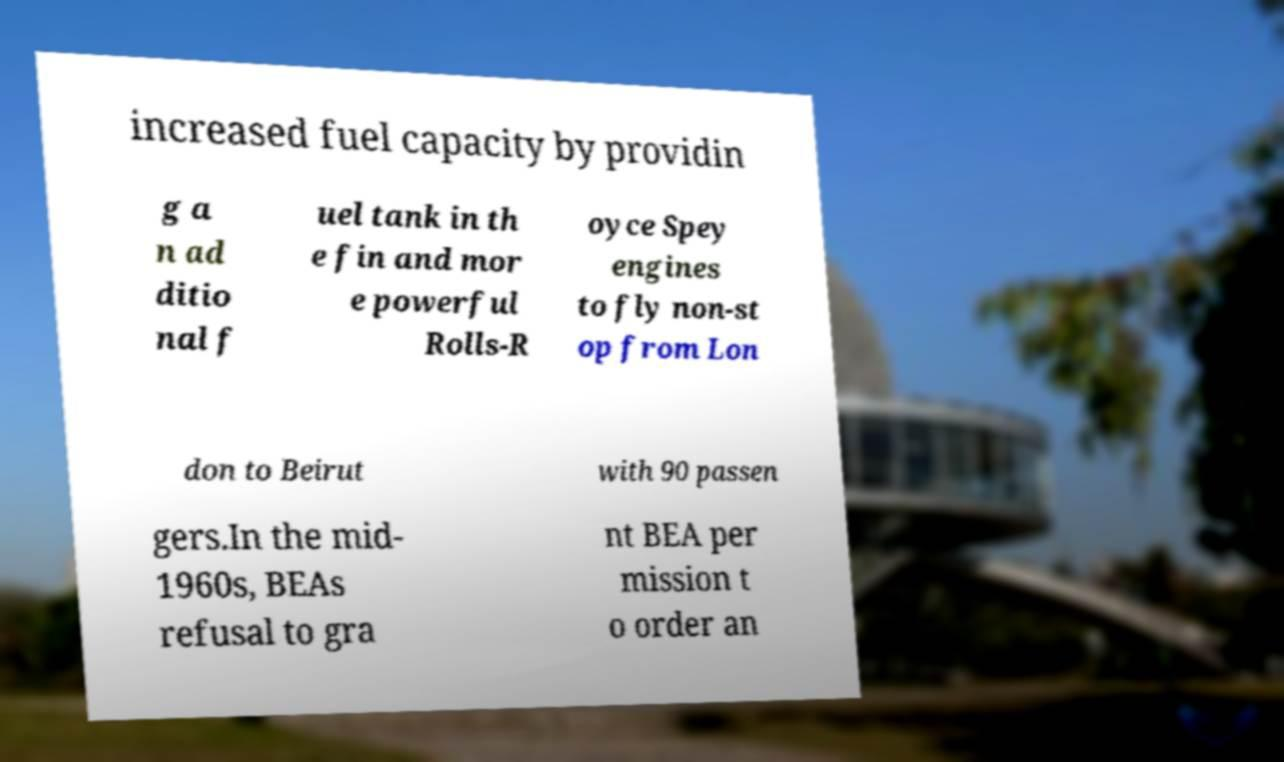Can you read and provide the text displayed in the image?This photo seems to have some interesting text. Can you extract and type it out for me? increased fuel capacity by providin g a n ad ditio nal f uel tank in th e fin and mor e powerful Rolls-R oyce Spey engines to fly non-st op from Lon don to Beirut with 90 passen gers.In the mid- 1960s, BEAs refusal to gra nt BEA per mission t o order an 